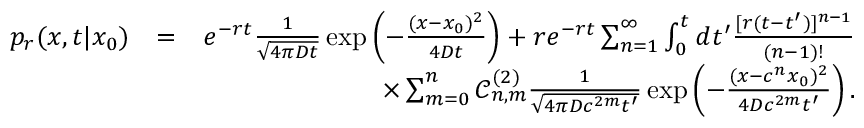Convert formula to latex. <formula><loc_0><loc_0><loc_500><loc_500>\begin{array} { r l r } { p _ { r } ( x , t | x _ { 0 } ) } & { = } & { e ^ { - r t } \frac { 1 } { \sqrt { 4 \pi D t } } \exp \left ( - \frac { ( x - x _ { 0 } ) ^ { 2 } } { 4 D t } \right ) + r e ^ { - r t } \sum _ { n = 1 } ^ { \infty } \int _ { 0 } ^ { t } d t ^ { \prime } \frac { [ r ( t - t ^ { \prime } ) ] ^ { n - 1 } } { ( n - 1 ) ! } } \\ & { \times \sum _ { m = 0 } ^ { n } \mathcal { C } _ { n , m } ^ { ( 2 ) } \frac { 1 } { \sqrt { 4 \pi D c ^ { 2 m } t ^ { \prime } } } \exp \left ( - \frac { ( x - c ^ { n } x _ { 0 } ) ^ { 2 } } { 4 D c ^ { 2 m } t ^ { \prime } } \right ) . } \end{array}</formula> 